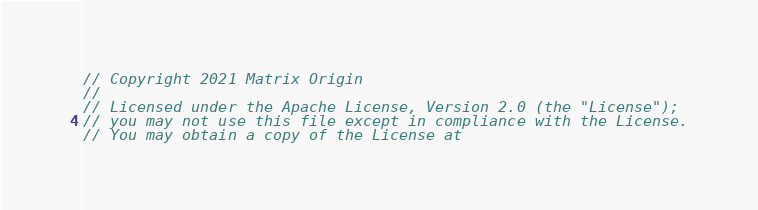Convert code to text. <code><loc_0><loc_0><loc_500><loc_500><_Go_>// Copyright 2021 Matrix Origin
//
// Licensed under the Apache License, Version 2.0 (the "License");
// you may not use this file except in compliance with the License.
// You may obtain a copy of the License at</code> 